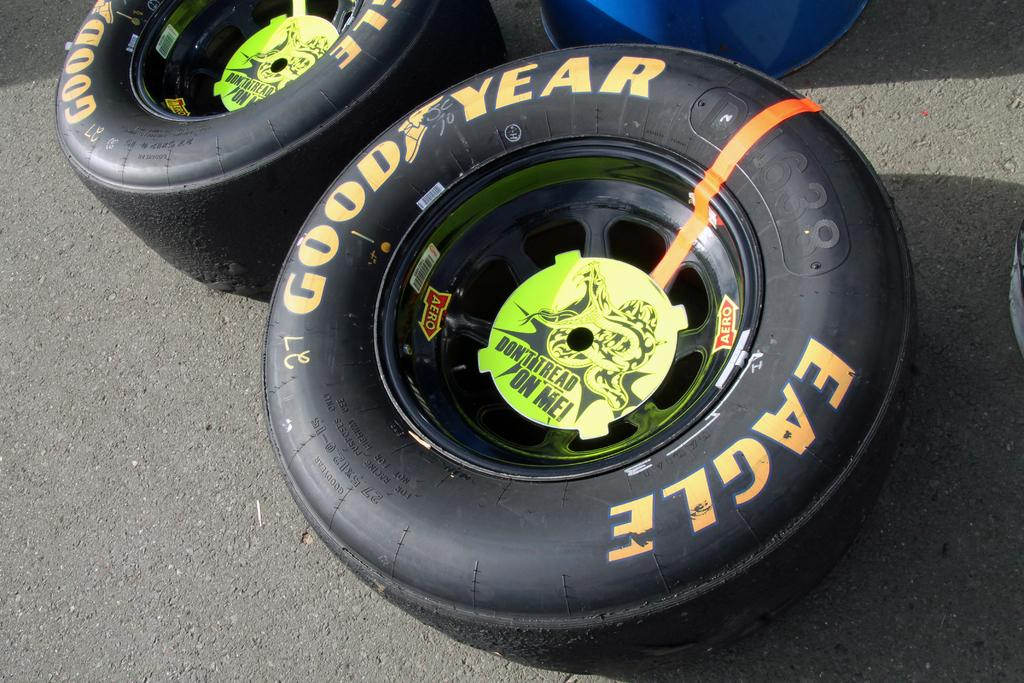What type of objects can be seen in the image? There are tyres in the image. Can you describe the object on the road? There is an object on the road in the image, but the specific details are not provided. How many boats are visible in the image? There are no boats present in the image. What type of hand is shown interacting with the tyres in the image? There is no hand shown interacting with the tyres in the image. 